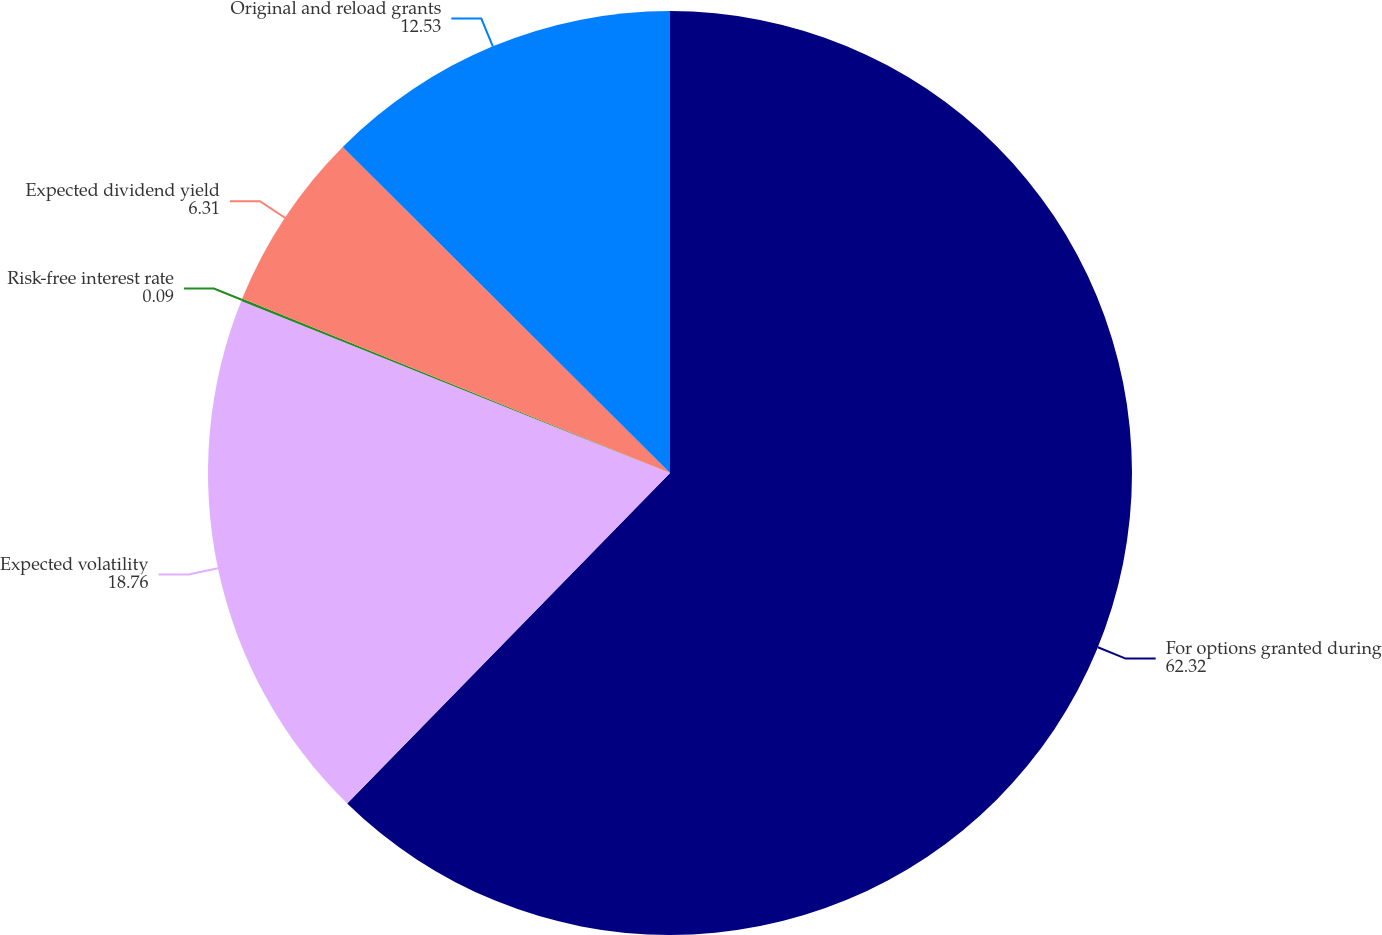Convert chart. <chart><loc_0><loc_0><loc_500><loc_500><pie_chart><fcel>For options granted during<fcel>Expected volatility<fcel>Risk-free interest rate<fcel>Expected dividend yield<fcel>Original and reload grants<nl><fcel>62.32%<fcel>18.76%<fcel>0.09%<fcel>6.31%<fcel>12.53%<nl></chart> 